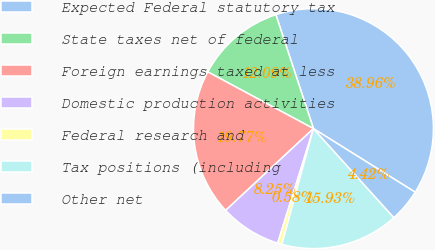<chart> <loc_0><loc_0><loc_500><loc_500><pie_chart><fcel>Expected Federal statutory tax<fcel>State taxes net of federal<fcel>Foreign earnings taxed at less<fcel>Domestic production activities<fcel>Federal research and<fcel>Tax positions (including<fcel>Other net<nl><fcel>38.96%<fcel>12.09%<fcel>19.77%<fcel>8.25%<fcel>0.58%<fcel>15.93%<fcel>4.42%<nl></chart> 